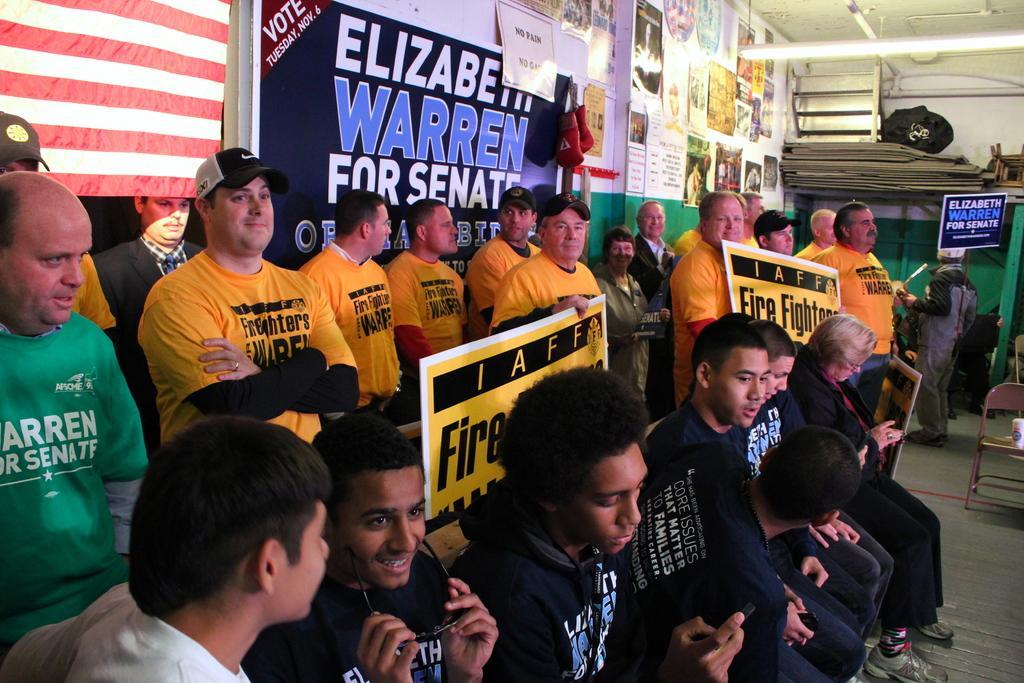Could you give a brief overview of what you see in this image? In this image we can see few persons are sitting and among them a man is holding goggles and another man is holding a mobile in their hands. In the background few persons are standing and few of them are holding boards in their hands and we can see a flag, light hanging to the roof top, posters and boards on the wall, cup on a chair and other objects. 